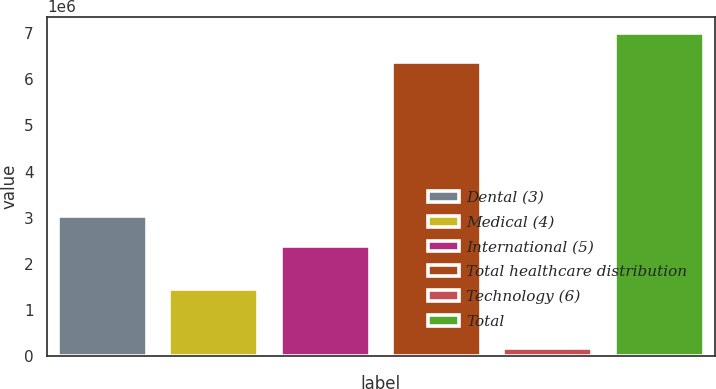Convert chart. <chart><loc_0><loc_0><loc_500><loc_500><bar_chart><fcel>Dental (3)<fcel>Medical (4)<fcel>International (5)<fcel>Total healthcare distribution<fcel>Technology (6)<fcel>Total<nl><fcel>3.03462e+06<fcel>1.4571e+06<fcel>2.3981e+06<fcel>6.36513e+06<fcel>173208<fcel>7.00164e+06<nl></chart> 